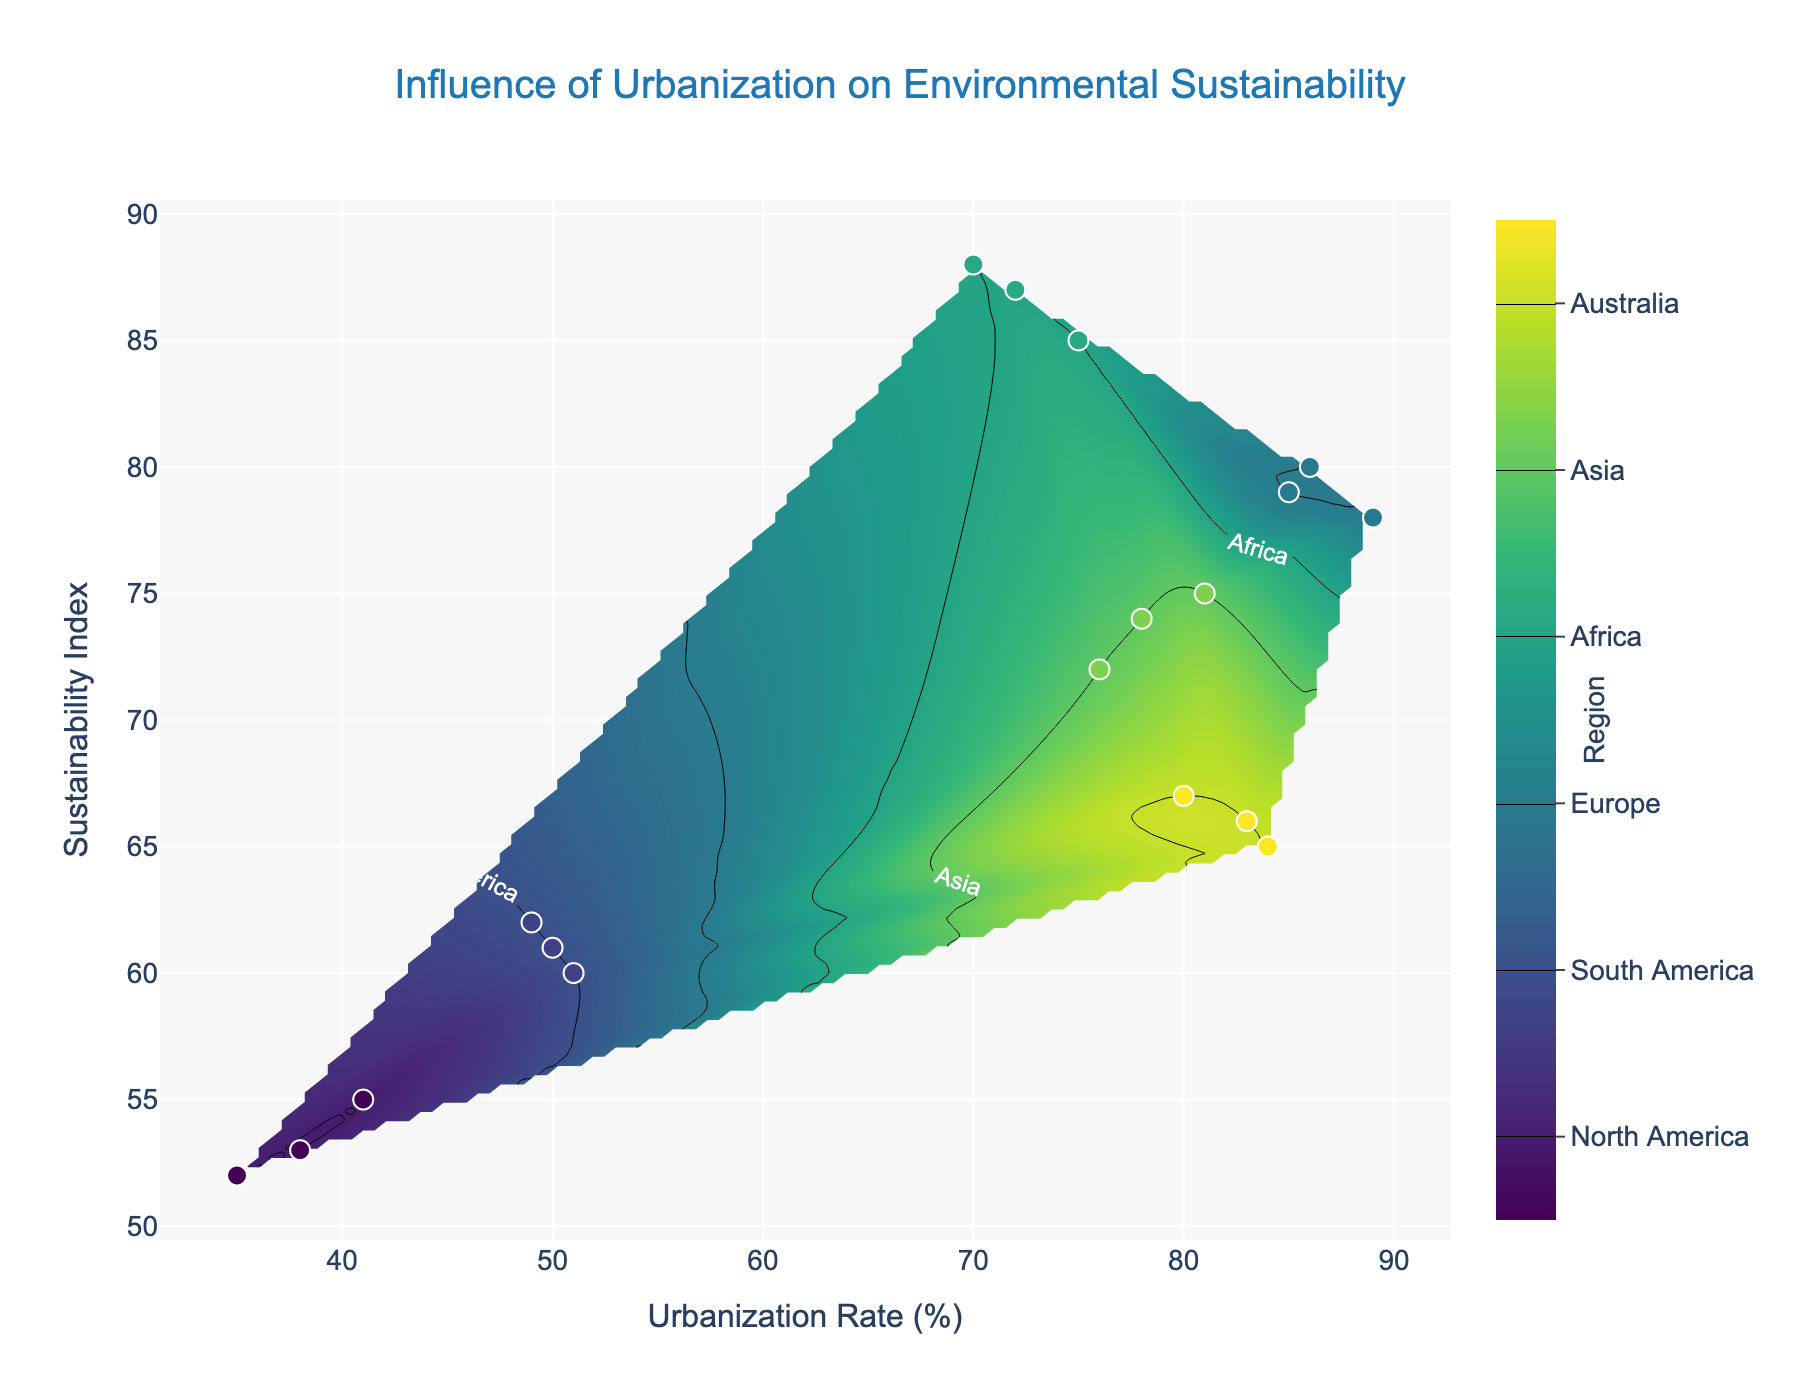What's the title of the contour plot? The title is usually displayed at the top of the plot. It's meant to give a concise summary of what the plot represents. In this case, the title is located at the center top and reads 'Influence of Urbanization on Environmental Sustainability'.
Answer: Influence of Urbanization on Environmental Sustainability What is the range of the Urbanization Rate axis? To determine this, we can look at the x-axis at the bottom of the plot. It represents Urbanization Rate and has numbers that show its range. The minimum and maximum values give the range.
Answer: 35% to 89% Which region has the highest Sustainability Index and what is its value? By examining the scatter points on the plot, we can identify the region with the highest Sustainability Index value. The corresponding value is found along the y-axis. The highest point belongs to Europe.
Answer: Europe, 88 Is there any region that appears multiple times on the plot? We need to look for repeated occurrences of regions in the scatter plot. Here, North America, South America, Europe, Africa, Asia, and Australia appear more than once.
Answer: Yes, North America, South America, Europe, Africa, Asia, and Australia What is the average Urbanization Rate of the data points? To find the average Urbanization Rate, sum all the Urbanization Rates and divide by the number of data points. Calculations: (81+84+75+41+51+86+76+80+70+35+49+89+78+83+72+38+50+85)/18 = 68.1
Answer: 68.1% Compare the Urbanization Rates between North America and Europe. Which has a higher average? First, isolate the Urbanization Rates for North America (81, 76, 78) and Europe (75, 70, 72). Then find the average for each: North America = (81+76+78)/3 = 78.33, Europe = (75+70+72)/3 = 72.33. Compare the results.
Answer: North America Describe the overall trend between Urbanization Rate and Sustainability Index seen in the contour plot. By observing the general pattern in the contour lines and scatter points, the plot indicates a general trend where higher Urbanization Rates do not directly correlate with higher Sustainability Indexes universally, but regions with high Urbanization Rates like Europe and Australia also have high Sustainability Indexes.
Answer: Variable trend with some regions showing positive correlation Which region has the most varied Sustainability Index values? We search for the region that shows a wide range of Sustainability Index values. North America varies significantly with values 75, 72, and 74.
Answer: North America 